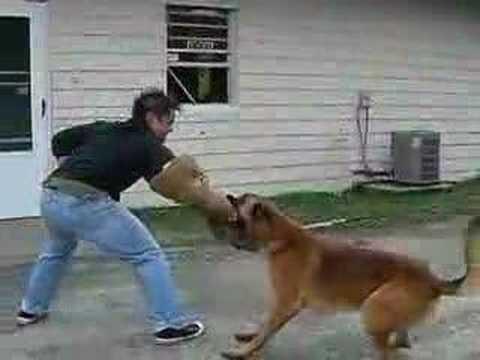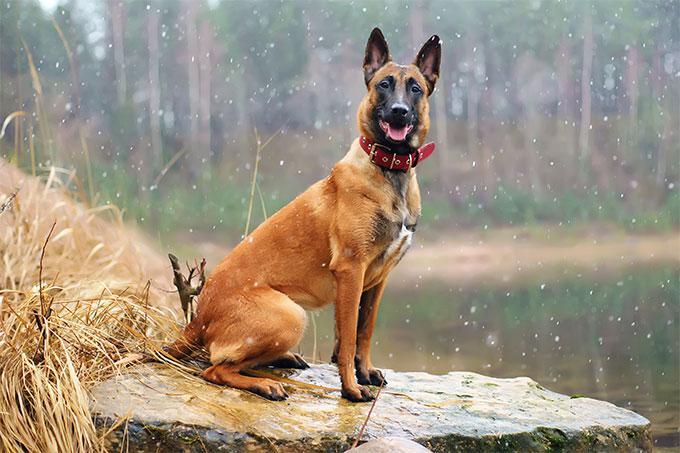The first image is the image on the left, the second image is the image on the right. For the images displayed, is the sentence "At least one dog is biting someone." factually correct? Answer yes or no. Yes. 